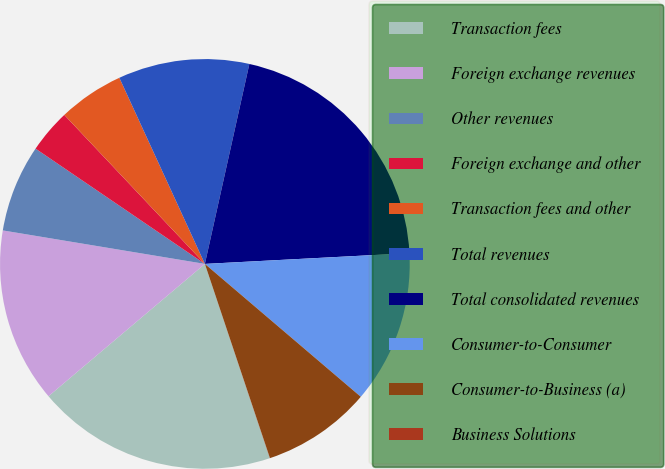Convert chart to OTSL. <chart><loc_0><loc_0><loc_500><loc_500><pie_chart><fcel>Transaction fees<fcel>Foreign exchange revenues<fcel>Other revenues<fcel>Foreign exchange and other<fcel>Transaction fees and other<fcel>Total revenues<fcel>Total consolidated revenues<fcel>Consumer-to-Consumer<fcel>Consumer-to-Business (a)<fcel>Business Solutions<nl><fcel>18.96%<fcel>13.79%<fcel>6.9%<fcel>3.45%<fcel>5.18%<fcel>10.34%<fcel>20.68%<fcel>12.07%<fcel>8.62%<fcel>0.01%<nl></chart> 